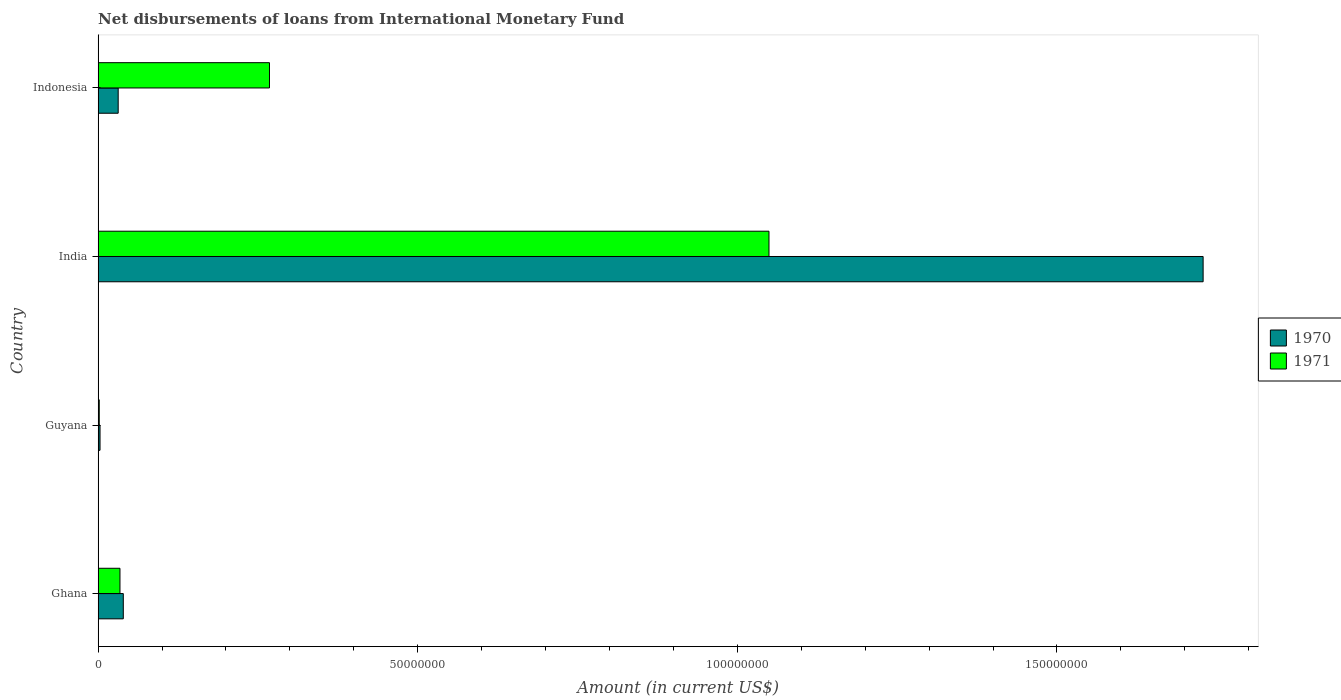How many groups of bars are there?
Your answer should be compact. 4. Are the number of bars on each tick of the Y-axis equal?
Provide a succinct answer. Yes. In how many cases, is the number of bars for a given country not equal to the number of legend labels?
Make the answer very short. 0. What is the amount of loans disbursed in 1971 in India?
Your response must be concise. 1.05e+08. Across all countries, what is the maximum amount of loans disbursed in 1970?
Ensure brevity in your answer.  1.73e+08. Across all countries, what is the minimum amount of loans disbursed in 1970?
Ensure brevity in your answer.  2.99e+05. In which country was the amount of loans disbursed in 1970 maximum?
Your answer should be very brief. India. In which country was the amount of loans disbursed in 1970 minimum?
Keep it short and to the point. Guyana. What is the total amount of loans disbursed in 1971 in the graph?
Your response must be concise. 1.35e+08. What is the difference between the amount of loans disbursed in 1971 in Ghana and that in India?
Your answer should be compact. -1.02e+08. What is the difference between the amount of loans disbursed in 1970 in Guyana and the amount of loans disbursed in 1971 in Indonesia?
Provide a short and direct response. -2.65e+07. What is the average amount of loans disbursed in 1971 per country?
Provide a short and direct response. 3.38e+07. What is the difference between the amount of loans disbursed in 1970 and amount of loans disbursed in 1971 in India?
Make the answer very short. 6.79e+07. What is the ratio of the amount of loans disbursed in 1970 in Ghana to that in India?
Your answer should be very brief. 0.02. Is the amount of loans disbursed in 1971 in Guyana less than that in India?
Ensure brevity in your answer.  Yes. What is the difference between the highest and the second highest amount of loans disbursed in 1970?
Your answer should be compact. 1.69e+08. What is the difference between the highest and the lowest amount of loans disbursed in 1971?
Make the answer very short. 1.05e+08. In how many countries, is the amount of loans disbursed in 1971 greater than the average amount of loans disbursed in 1971 taken over all countries?
Offer a very short reply. 1. Is the sum of the amount of loans disbursed in 1970 in Ghana and Indonesia greater than the maximum amount of loans disbursed in 1971 across all countries?
Give a very brief answer. No. Are all the bars in the graph horizontal?
Provide a short and direct response. Yes. What is the difference between two consecutive major ticks on the X-axis?
Offer a very short reply. 5.00e+07. Does the graph contain any zero values?
Make the answer very short. No. Does the graph contain grids?
Keep it short and to the point. No. Where does the legend appear in the graph?
Give a very brief answer. Center right. What is the title of the graph?
Offer a terse response. Net disbursements of loans from International Monetary Fund. What is the Amount (in current US$) of 1970 in Ghana?
Give a very brief answer. 3.94e+06. What is the Amount (in current US$) in 1971 in Ghana?
Your answer should be very brief. 3.42e+06. What is the Amount (in current US$) in 1970 in Guyana?
Provide a short and direct response. 2.99e+05. What is the Amount (in current US$) of 1971 in Guyana?
Offer a terse response. 1.76e+05. What is the Amount (in current US$) of 1970 in India?
Provide a succinct answer. 1.73e+08. What is the Amount (in current US$) of 1971 in India?
Your answer should be compact. 1.05e+08. What is the Amount (in current US$) of 1970 in Indonesia?
Offer a terse response. 3.14e+06. What is the Amount (in current US$) of 1971 in Indonesia?
Ensure brevity in your answer.  2.68e+07. Across all countries, what is the maximum Amount (in current US$) in 1970?
Offer a terse response. 1.73e+08. Across all countries, what is the maximum Amount (in current US$) of 1971?
Provide a short and direct response. 1.05e+08. Across all countries, what is the minimum Amount (in current US$) of 1970?
Your answer should be very brief. 2.99e+05. Across all countries, what is the minimum Amount (in current US$) in 1971?
Keep it short and to the point. 1.76e+05. What is the total Amount (in current US$) of 1970 in the graph?
Your answer should be compact. 1.80e+08. What is the total Amount (in current US$) of 1971 in the graph?
Keep it short and to the point. 1.35e+08. What is the difference between the Amount (in current US$) in 1970 in Ghana and that in Guyana?
Your answer should be compact. 3.64e+06. What is the difference between the Amount (in current US$) in 1971 in Ghana and that in Guyana?
Keep it short and to the point. 3.24e+06. What is the difference between the Amount (in current US$) of 1970 in Ghana and that in India?
Your answer should be very brief. -1.69e+08. What is the difference between the Amount (in current US$) of 1971 in Ghana and that in India?
Offer a very short reply. -1.02e+08. What is the difference between the Amount (in current US$) of 1970 in Ghana and that in Indonesia?
Provide a short and direct response. 7.99e+05. What is the difference between the Amount (in current US$) of 1971 in Ghana and that in Indonesia?
Offer a terse response. -2.34e+07. What is the difference between the Amount (in current US$) in 1970 in Guyana and that in India?
Your answer should be compact. -1.73e+08. What is the difference between the Amount (in current US$) of 1971 in Guyana and that in India?
Give a very brief answer. -1.05e+08. What is the difference between the Amount (in current US$) in 1970 in Guyana and that in Indonesia?
Ensure brevity in your answer.  -2.84e+06. What is the difference between the Amount (in current US$) of 1971 in Guyana and that in Indonesia?
Keep it short and to the point. -2.66e+07. What is the difference between the Amount (in current US$) of 1970 in India and that in Indonesia?
Offer a terse response. 1.70e+08. What is the difference between the Amount (in current US$) of 1971 in India and that in Indonesia?
Ensure brevity in your answer.  7.81e+07. What is the difference between the Amount (in current US$) of 1970 in Ghana and the Amount (in current US$) of 1971 in Guyana?
Offer a very short reply. 3.76e+06. What is the difference between the Amount (in current US$) in 1970 in Ghana and the Amount (in current US$) in 1971 in India?
Offer a terse response. -1.01e+08. What is the difference between the Amount (in current US$) in 1970 in Ghana and the Amount (in current US$) in 1971 in Indonesia?
Ensure brevity in your answer.  -2.29e+07. What is the difference between the Amount (in current US$) in 1970 in Guyana and the Amount (in current US$) in 1971 in India?
Provide a succinct answer. -1.05e+08. What is the difference between the Amount (in current US$) of 1970 in Guyana and the Amount (in current US$) of 1971 in Indonesia?
Provide a short and direct response. -2.65e+07. What is the difference between the Amount (in current US$) in 1970 in India and the Amount (in current US$) in 1971 in Indonesia?
Your answer should be very brief. 1.46e+08. What is the average Amount (in current US$) in 1970 per country?
Offer a very short reply. 4.51e+07. What is the average Amount (in current US$) in 1971 per country?
Offer a terse response. 3.38e+07. What is the difference between the Amount (in current US$) in 1970 and Amount (in current US$) in 1971 in Ghana?
Your response must be concise. 5.20e+05. What is the difference between the Amount (in current US$) of 1970 and Amount (in current US$) of 1971 in Guyana?
Keep it short and to the point. 1.23e+05. What is the difference between the Amount (in current US$) of 1970 and Amount (in current US$) of 1971 in India?
Your response must be concise. 6.79e+07. What is the difference between the Amount (in current US$) of 1970 and Amount (in current US$) of 1971 in Indonesia?
Make the answer very short. -2.37e+07. What is the ratio of the Amount (in current US$) in 1970 in Ghana to that in Guyana?
Provide a short and direct response. 13.17. What is the ratio of the Amount (in current US$) in 1971 in Ghana to that in Guyana?
Offer a terse response. 19.42. What is the ratio of the Amount (in current US$) in 1970 in Ghana to that in India?
Ensure brevity in your answer.  0.02. What is the ratio of the Amount (in current US$) in 1971 in Ghana to that in India?
Offer a very short reply. 0.03. What is the ratio of the Amount (in current US$) in 1970 in Ghana to that in Indonesia?
Provide a short and direct response. 1.25. What is the ratio of the Amount (in current US$) of 1971 in Ghana to that in Indonesia?
Give a very brief answer. 0.13. What is the ratio of the Amount (in current US$) of 1970 in Guyana to that in India?
Provide a succinct answer. 0. What is the ratio of the Amount (in current US$) of 1971 in Guyana to that in India?
Your answer should be compact. 0. What is the ratio of the Amount (in current US$) in 1970 in Guyana to that in Indonesia?
Offer a terse response. 0.1. What is the ratio of the Amount (in current US$) in 1971 in Guyana to that in Indonesia?
Offer a very short reply. 0.01. What is the ratio of the Amount (in current US$) of 1970 in India to that in Indonesia?
Make the answer very short. 55.07. What is the ratio of the Amount (in current US$) in 1971 in India to that in Indonesia?
Offer a very short reply. 3.91. What is the difference between the highest and the second highest Amount (in current US$) in 1970?
Give a very brief answer. 1.69e+08. What is the difference between the highest and the second highest Amount (in current US$) in 1971?
Offer a terse response. 7.81e+07. What is the difference between the highest and the lowest Amount (in current US$) of 1970?
Ensure brevity in your answer.  1.73e+08. What is the difference between the highest and the lowest Amount (in current US$) in 1971?
Offer a very short reply. 1.05e+08. 